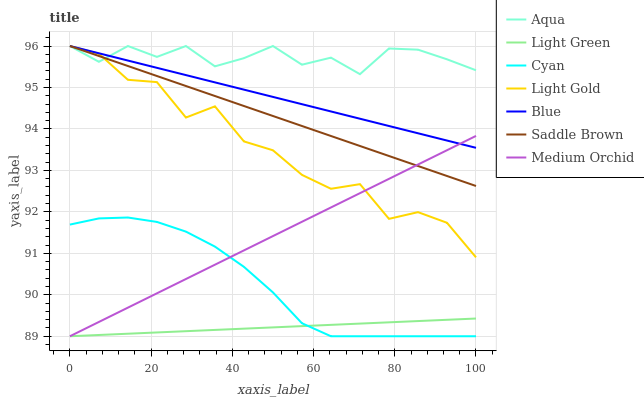Does Light Green have the minimum area under the curve?
Answer yes or no. Yes. Does Aqua have the maximum area under the curve?
Answer yes or no. Yes. Does Medium Orchid have the minimum area under the curve?
Answer yes or no. No. Does Medium Orchid have the maximum area under the curve?
Answer yes or no. No. Is Light Green the smoothest?
Answer yes or no. Yes. Is Light Gold the roughest?
Answer yes or no. Yes. Is Medium Orchid the smoothest?
Answer yes or no. No. Is Medium Orchid the roughest?
Answer yes or no. No. Does Medium Orchid have the lowest value?
Answer yes or no. Yes. Does Aqua have the lowest value?
Answer yes or no. No. Does Saddle Brown have the highest value?
Answer yes or no. Yes. Does Medium Orchid have the highest value?
Answer yes or no. No. Is Cyan less than Light Gold?
Answer yes or no. Yes. Is Blue greater than Light Green?
Answer yes or no. Yes. Does Medium Orchid intersect Saddle Brown?
Answer yes or no. Yes. Is Medium Orchid less than Saddle Brown?
Answer yes or no. No. Is Medium Orchid greater than Saddle Brown?
Answer yes or no. No. Does Cyan intersect Light Gold?
Answer yes or no. No. 